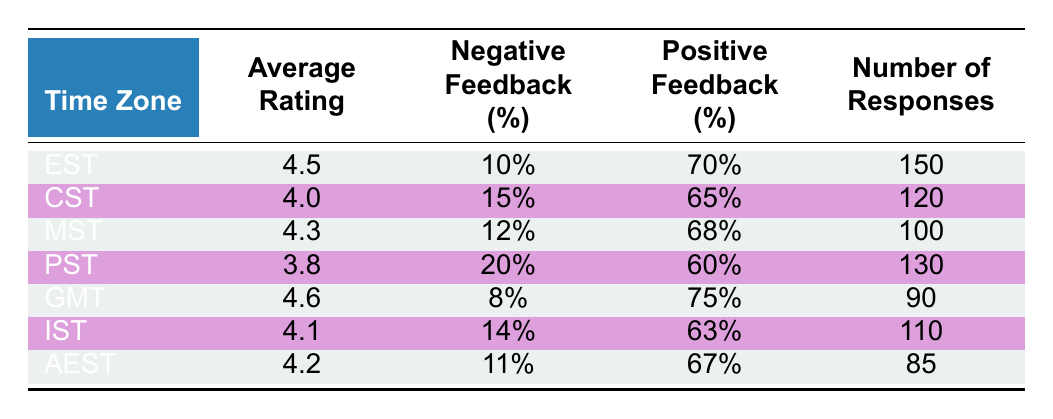What is the average rating for the Pacific Standard Time zone? The table shows the data for each time zone, and for Pacific Standard Time (PST), the average rating is listed as 3.8.
Answer: 3.8 Which time zone has the highest positive feedback percentage? Looking at the positive feedback percentages listed, Greenwich Mean Time (GMT) has the highest at 75%.
Answer: 75% What is the total number of responses from all time zones? To find the total number of responses, we add the responses from each time zone: 150 (EST) + 120 (CST) + 100 (MST) + 130 (PST) + 90 (GMT) + 110 (IST) + 85 (AEST) = 785.
Answer: 785 Is the negative feedback percentage for India Standard Time higher than that of Mountain Standard Time? India Standard Time (IST) has a negative feedback percentage of 14%, while Mountain Standard Time (MST) has a negative feedback percentage of 12%. Since 14% is greater than 12%, the statement is true.
Answer: Yes What is the difference in average ratings between the highest and lowest rated time zones? The highest average rating is for Greenwich Mean Time (GMT) at 4.6, and the lowest is for Pacific Standard Time (PST) at 3.8. The difference is 4.6 - 3.8 = 0.8.
Answer: 0.8 Which time zone has a negative feedback percentage less than 12%? Checking the table, only Greenwich Mean Time (GMT) has a negative feedback percentage of 8%, which is less than 12%.
Answer: Yes What is the average rating of the Central Standard Time zone? The average rating for Central Standard Time (CST) is directly provided in the table as 4.0.
Answer: 4.0 If you combine the positive feedback percentages of EST and GMT, what is the result? The positive feedback percentage for EST is 70% and for GMT is 75%. When combined, 70% + 75% = 145%.
Answer: 145% 